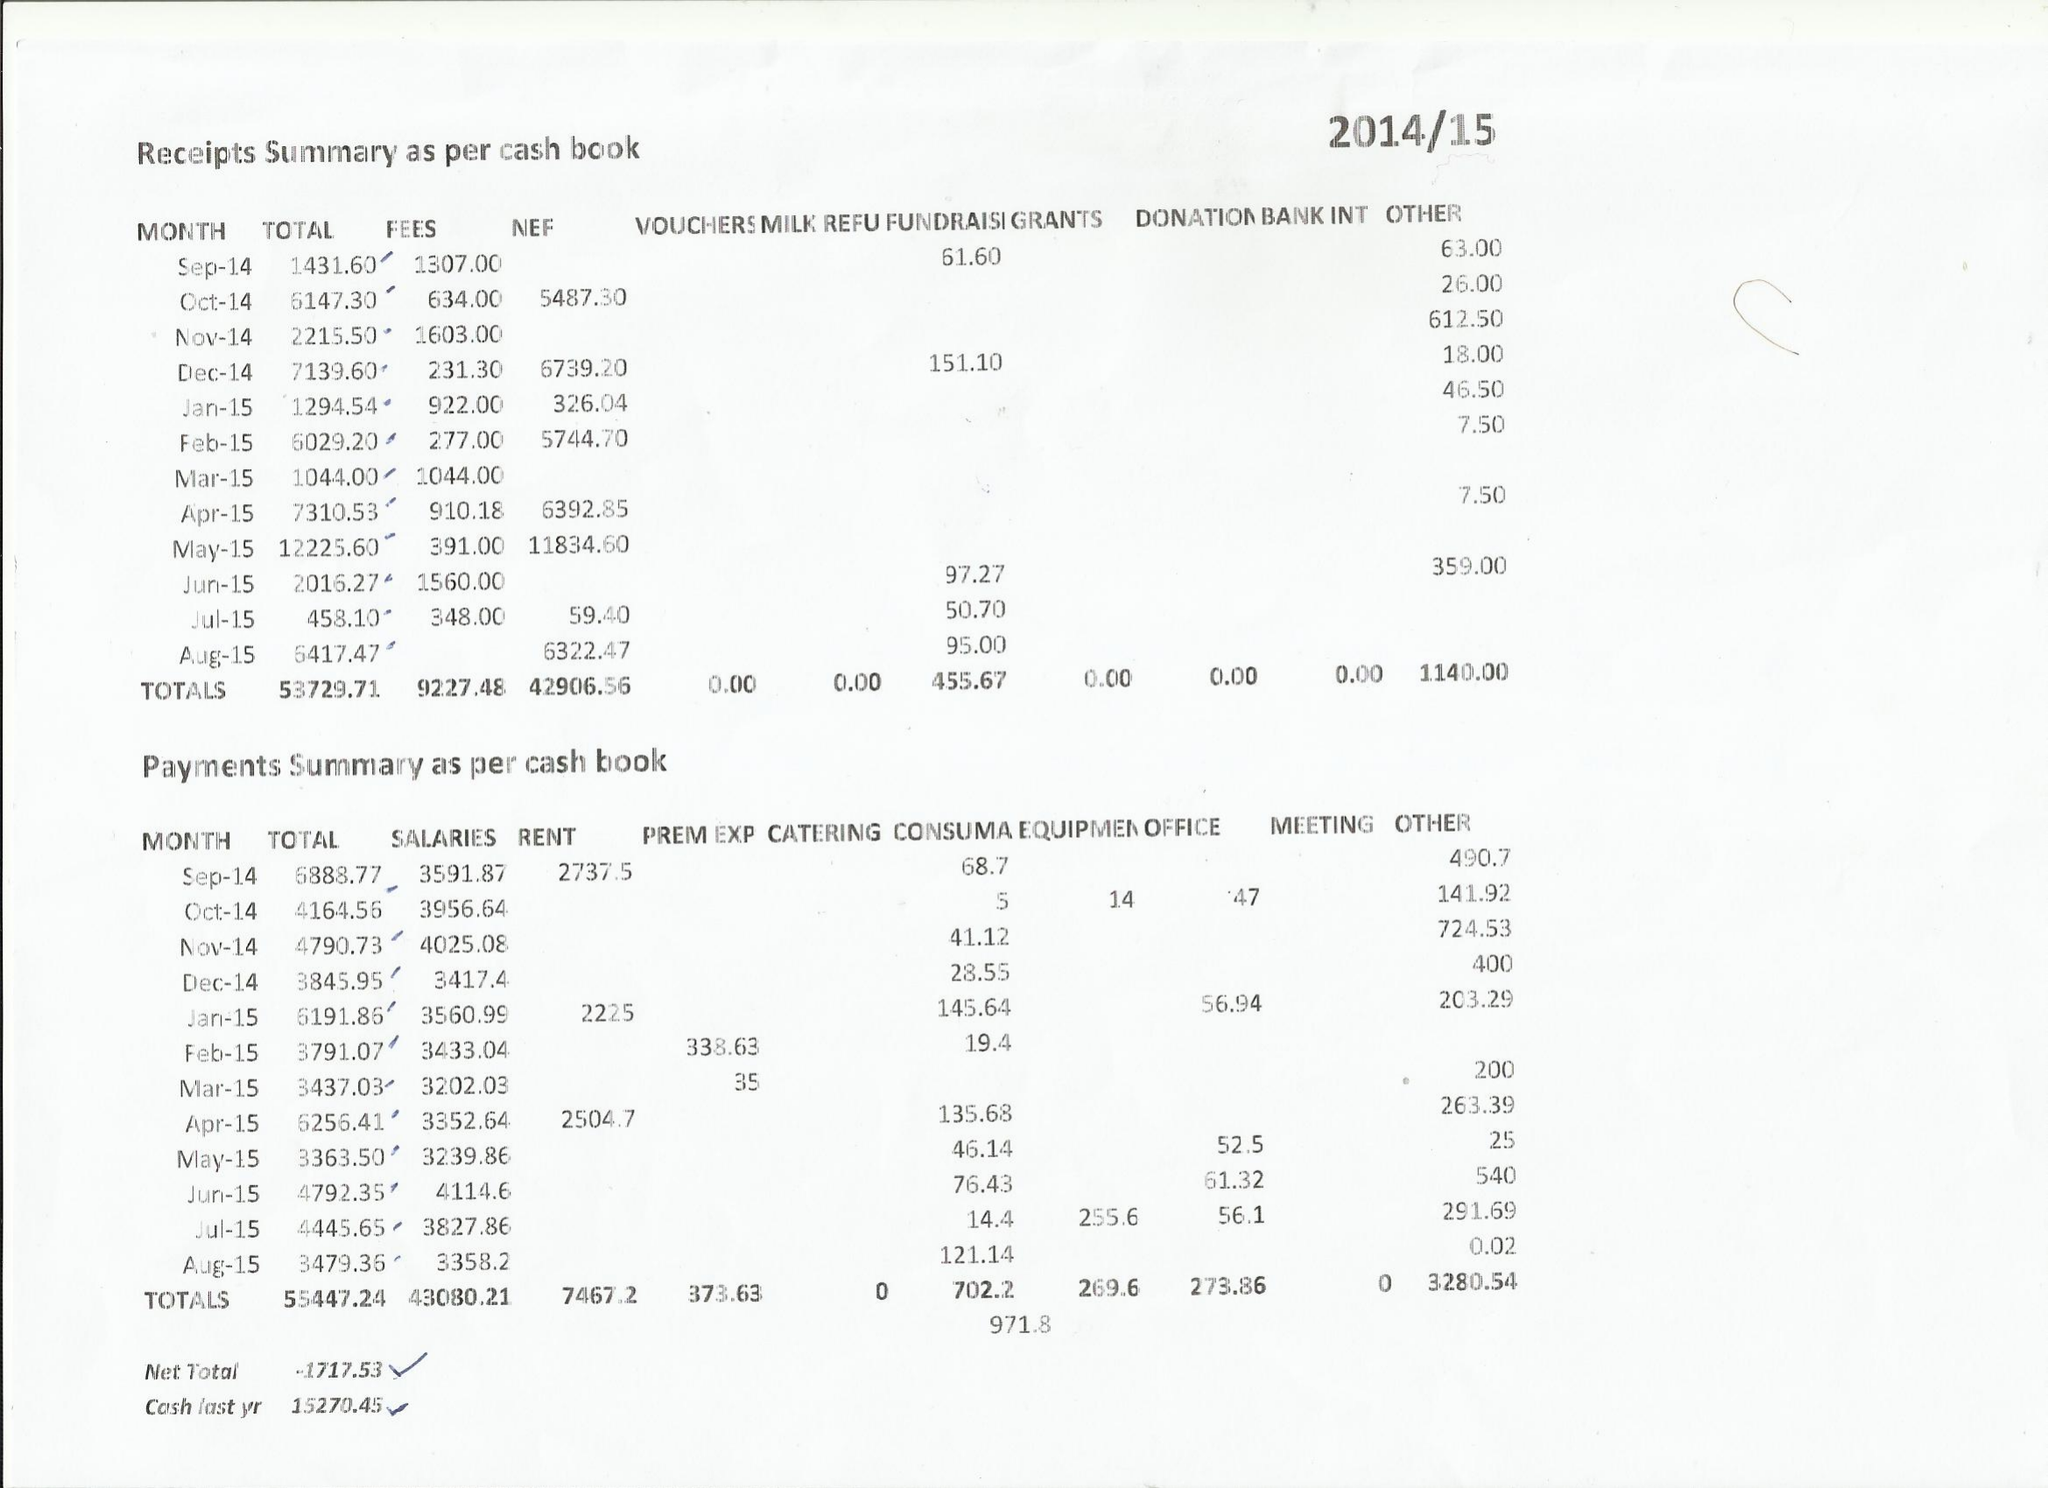What is the value for the address__street_line?
Answer the question using a single word or phrase. None 